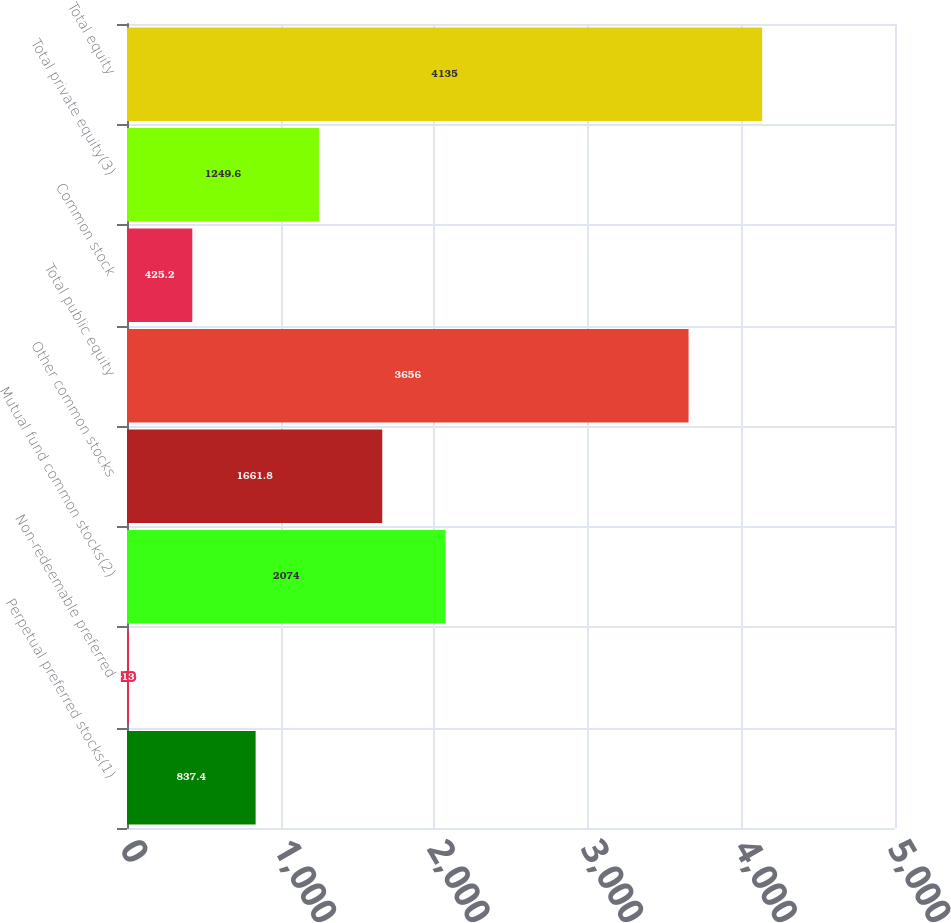Convert chart. <chart><loc_0><loc_0><loc_500><loc_500><bar_chart><fcel>Perpetual preferred stocks(1)<fcel>Non-redeemable preferred<fcel>Mutual fund common stocks(2)<fcel>Other common stocks<fcel>Total public equity<fcel>Common stock<fcel>Total private equity(3)<fcel>Total equity<nl><fcel>837.4<fcel>13<fcel>2074<fcel>1661.8<fcel>3656<fcel>425.2<fcel>1249.6<fcel>4135<nl></chart> 